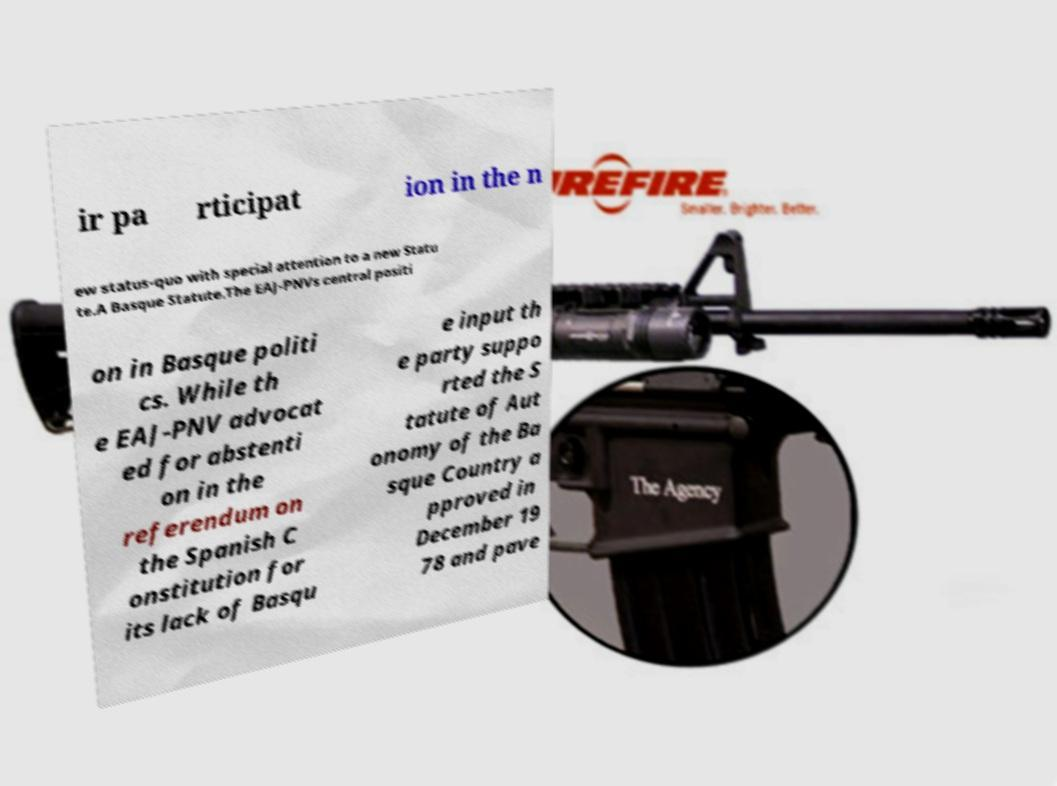Could you assist in decoding the text presented in this image and type it out clearly? ir pa rticipat ion in the n ew status-quo with special attention to a new Statu te.A Basque Statute.The EAJ-PNVs central positi on in Basque politi cs. While th e EAJ-PNV advocat ed for abstenti on in the referendum on the Spanish C onstitution for its lack of Basqu e input th e party suppo rted the S tatute of Aut onomy of the Ba sque Country a pproved in December 19 78 and pave 